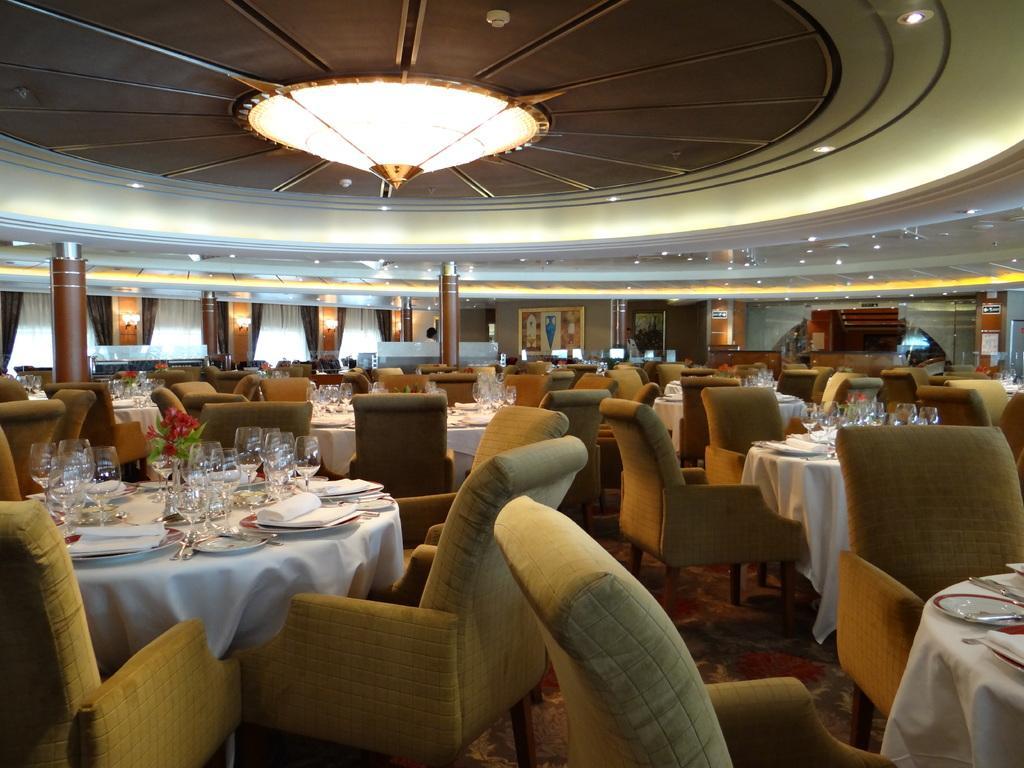How would you summarize this image in a sentence or two? This image is taken in a restaurant. In this image there are so many tables and chairs are arranged on the floor. On the tables there are so many glasses, plates, tissues and a few other objects. In the background there are a few frames hanging on the wall, curtains and pillars. At the top of the image there is a ceiling with lights. 